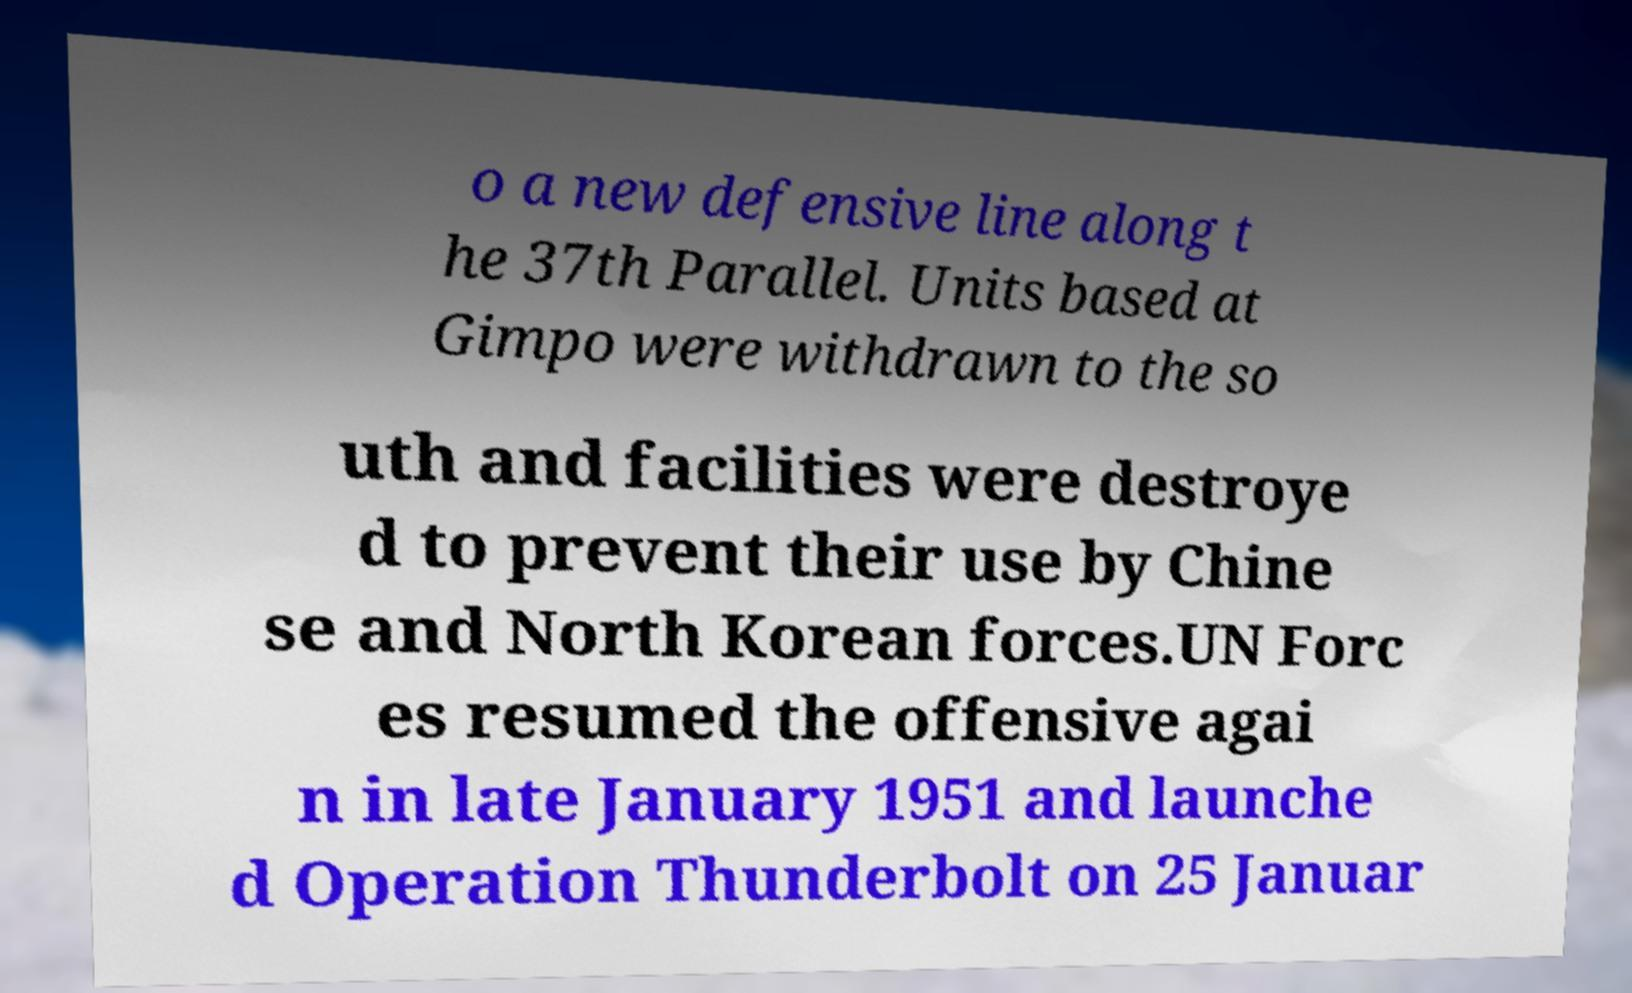What messages or text are displayed in this image? I need them in a readable, typed format. o a new defensive line along t he 37th Parallel. Units based at Gimpo were withdrawn to the so uth and facilities were destroye d to prevent their use by Chine se and North Korean forces.UN Forc es resumed the offensive agai n in late January 1951 and launche d Operation Thunderbolt on 25 Januar 